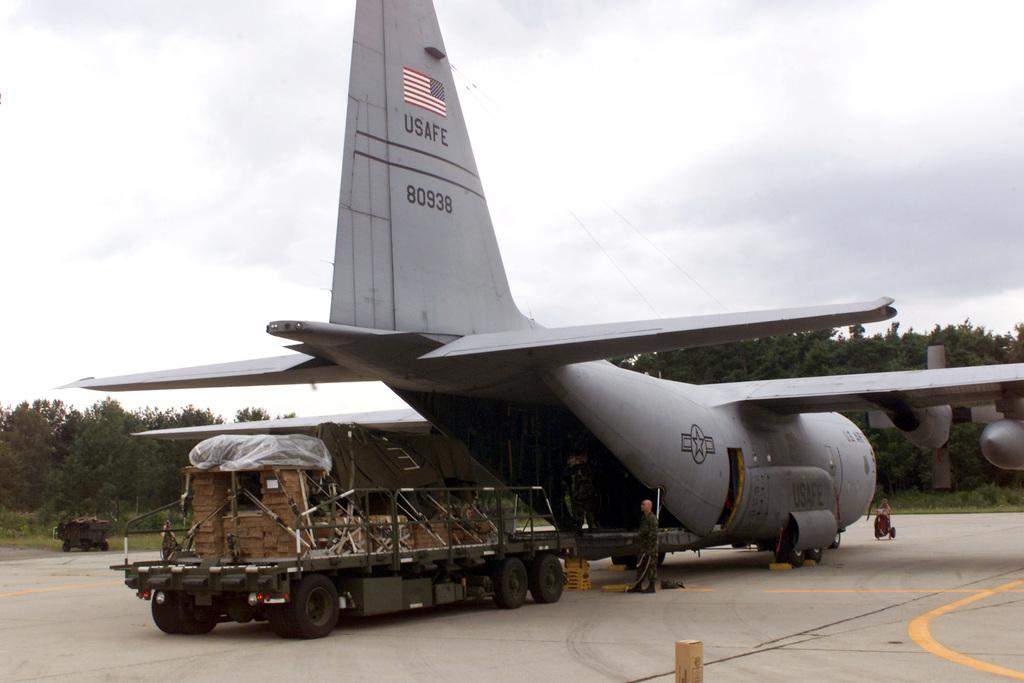What is the main subject of the image? The main subject of the image is an airplane. Where is the airplane located in the image? The airplane is in the center of the image. What can be seen in the background of the image? There are trees in the background of the image. What type of authority figure can be seen in the image? There is no authority figure present in the image; it features an airplane and trees in the background. What type of plough is being used in the image? There is no plough present in the image; it features an airplane and trees in the background. 